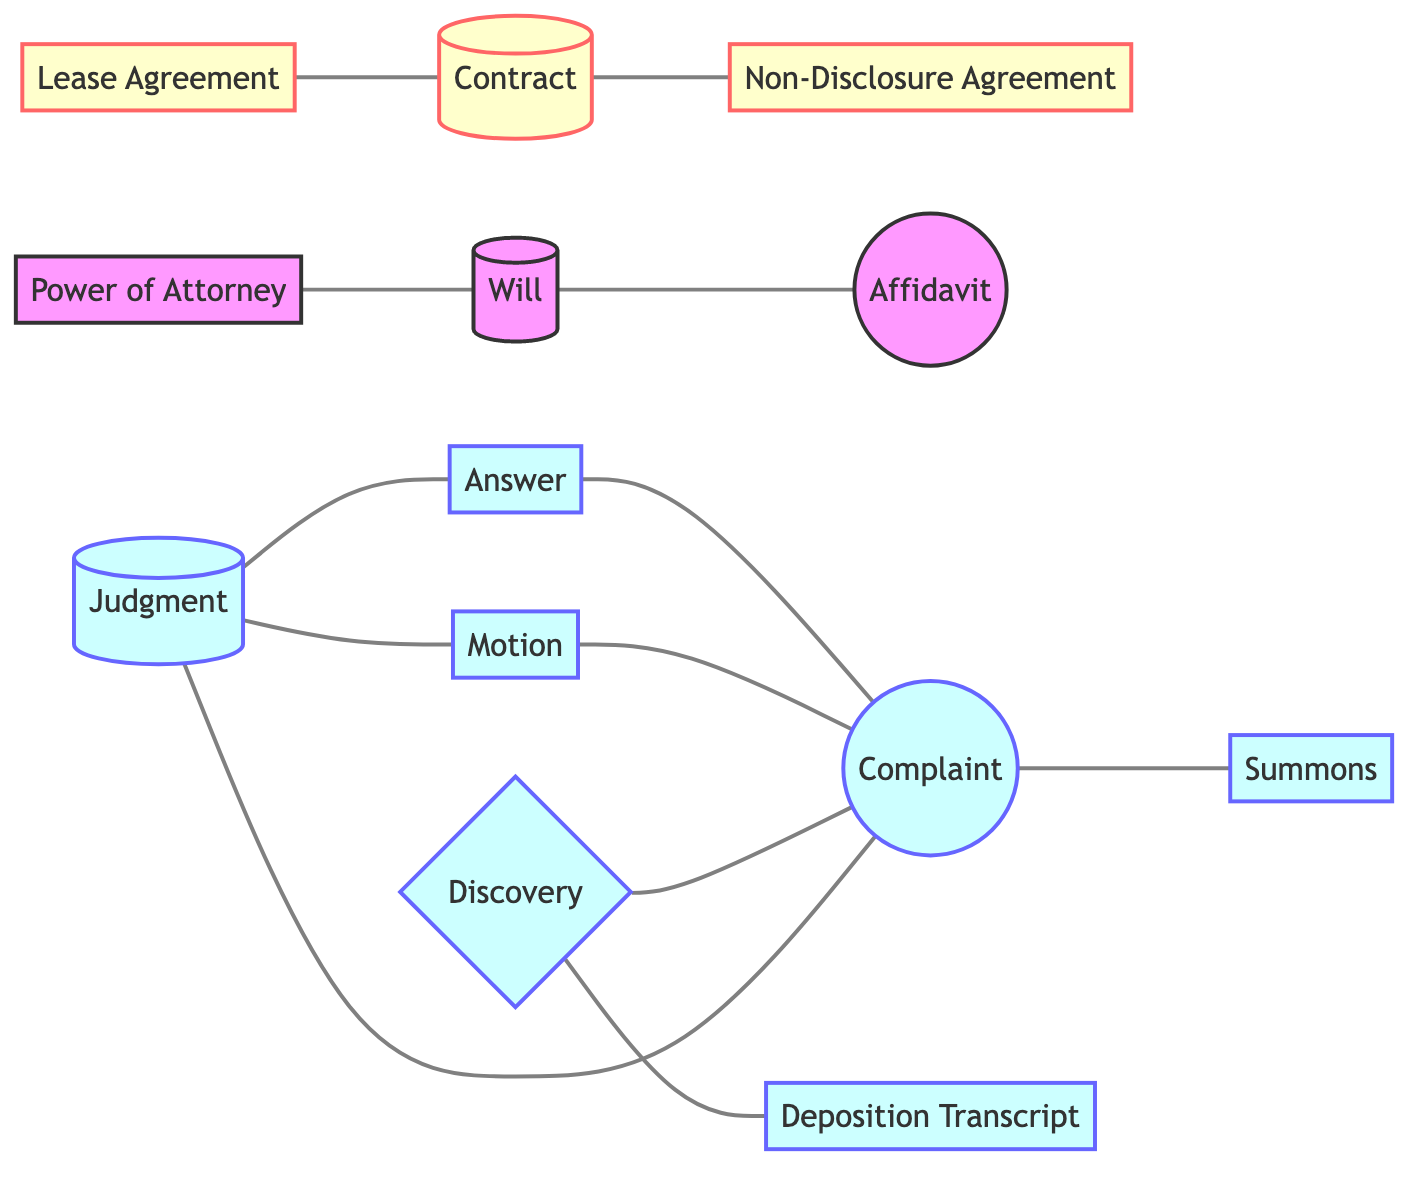What is the total number of nodes in the diagram? The diagram lists 13 distinct types of legal documents as nodes. Counting each one shows that there are 13 nodes in total.
Answer: 13 Which document directly connects to the Complaint? The edges show that the Complaint connects directly to the Answer, Motion, Discovery, and Summons, making these the documents intricately related to the Complaint.
Answer: Answer, Motion, Discovery, Summons How many types of agreements are represented in the graph? The diagram shows that there are three agreements specifically labeled as types: Contract, Lease Agreement, and Non-Disclosure Agreement. This makes a total of three types of agreements.
Answer: 3 What type of document is the Judgment connected to? The edges indicate that Judgment is connected to three documents: Complaint, Answer, and Motion, showing its role within the litigation process.
Answer: Complaint, Answer, Motion Which document precedes the Affidavit in the workflow? The diagram shows that the Will connects directly to the Affidavit, indicating that the Will is the document that precedes the Affidavit.
Answer: Will How many documents are classified under litigation? The diagram shows six documents specifically designated as litigation-related, which include Complaint, Answer, Motion, Summons, Discovery, and Judgment.
Answer: 6 What is the connection between Power of Attorney and Will? The diagram illustrates that the Power of Attorney connects directly to the Will, demonstrating a relationship between these two types of documents.
Answer: Will Which document does the Discovery connect to besides the Complaint? The edges in the diagram indicate that the Discovery connects to the Deposition Transcript, as well as to the Complaint. This implies an additional layer of complexity in their relationship.
Answer: Deposition Transcript 